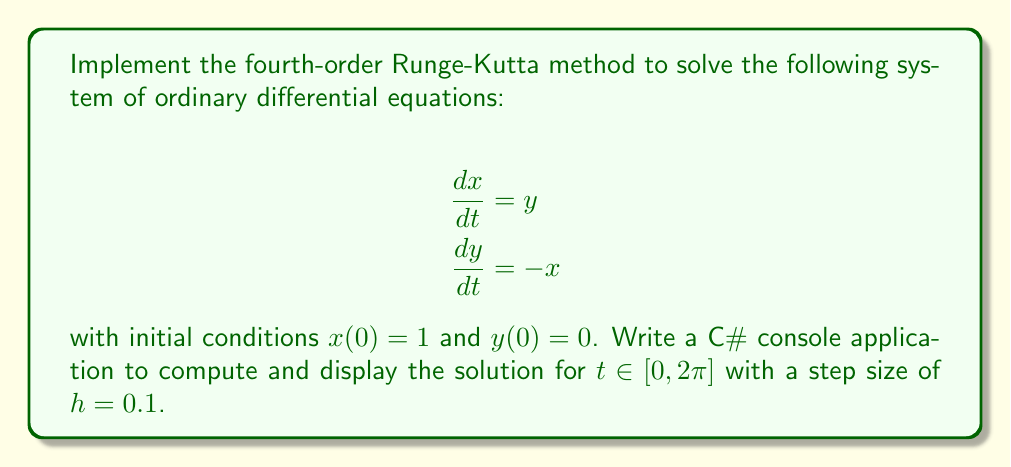Solve this math problem. To solve this system using the fourth-order Runge-Kutta method in C#, follow these steps:

1. Define the system of ODEs as functions:
```csharp
static double f1(double t, double x, double y) { return y; }
static double f2(double t, double x, double y) { return -x; }
```

2. Implement the Runge-Kutta method:
```csharp
static (double, double) RungeKutta4(double t, double x, double y, double h)
{
    double k1x = h * f1(t, x, y);
    double k1y = h * f2(t, x, y);
    
    double k2x = h * f1(t + 0.5 * h, x + 0.5 * k1x, y + 0.5 * k1y);
    double k2y = h * f2(t + 0.5 * h, x + 0.5 * k1x, y + 0.5 * k1y);
    
    double k3x = h * f1(t + 0.5 * h, x + 0.5 * k2x, y + 0.5 * k2y);
    double k3y = h * f2(t + 0.5 * h, x + 0.5 * k2x, y + 0.5 * k2y);
    
    double k4x = h * f1(t + h, x + k3x, y + k3y);
    double k4y = h * f2(t + h, x + k3x, y + k3y);
    
    double newX = x + (k1x + 2 * k2x + 2 * k3x + k4x) / 6;
    double newY = y + (k1y + 2 * k2y + 2 * k3y + k4y) / 6;
    
    return (newX, newY);
}
```

3. Set up the main program:
```csharp
static void Main(string[] args)
{
    double t = 0;
    double x = 1;
    double y = 0;
    double h = 0.1;
    double tMax = 2 * Math.PI;

    Console.WriteLine("t\tx\ty");
    Console.WriteLine($"{t:F4}\t{x:F4}\t{y:F4}");

    while (t < tMax)
    {
        (x, y) = RungeKutta4(t, x, y, h);
        t += h;
        Console.WriteLine($"{t:F4}\t{x:F4}\t{y:F4}");
    }
}
```

This implementation will solve the system of ODEs and display the results in the console. The solution represents the position $(x, y)$ of a particle moving in a circular path as a function of time $t$.
Answer: C# console app using fourth-order Runge-Kutta method to solve $\frac{dx}{dt} = y, \frac{dy}{dt} = -x$ with $x(0) = 1, y(0) = 0$ for $t \in [0, 2\pi], h = 0.1$. 